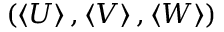<formula> <loc_0><loc_0><loc_500><loc_500>\left ( \left < U \right > , \left < V \right > , \left < W \right > \right )</formula> 